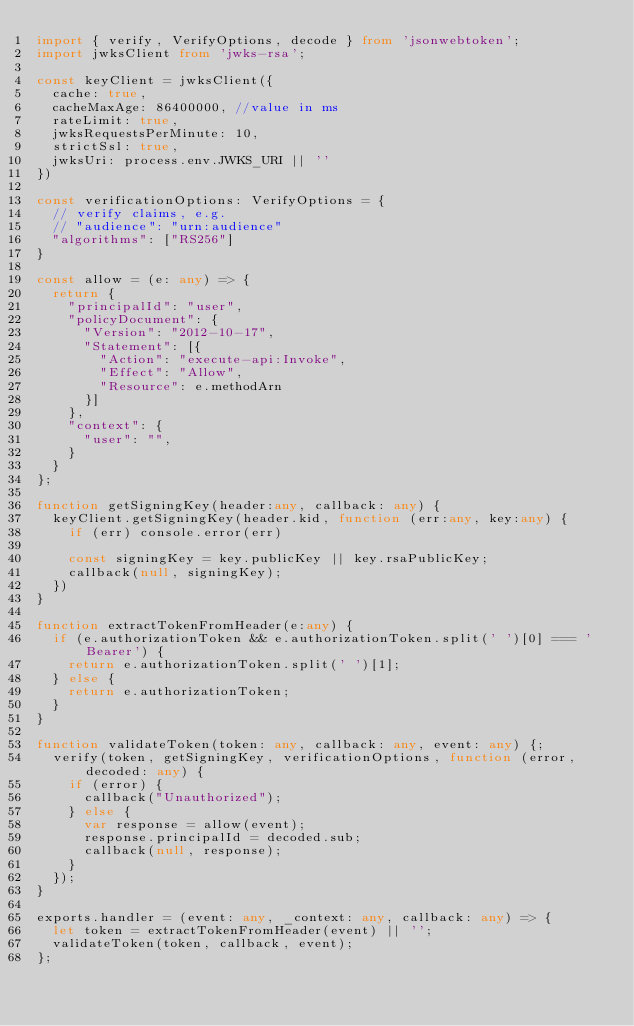<code> <loc_0><loc_0><loc_500><loc_500><_TypeScript_>import { verify, VerifyOptions, decode } from 'jsonwebtoken';
import jwksClient from 'jwks-rsa';

const keyClient = jwksClient({
  cache: true,
  cacheMaxAge: 86400000, //value in ms
  rateLimit: true,
  jwksRequestsPerMinute: 10,
  strictSsl: true,
  jwksUri: process.env.JWKS_URI || ''
})

const verificationOptions: VerifyOptions = {
  // verify claims, e.g.
  // "audience": "urn:audience"
  "algorithms": ["RS256"]
}

const allow = (e: any) => {
  return {
    "principalId": "user",
    "policyDocument": {
      "Version": "2012-10-17",
      "Statement": [{
        "Action": "execute-api:Invoke",
        "Effect": "Allow",
        "Resource": e.methodArn
      }]
    },
    "context": {
      "user": "",
    }
  }
};

function getSigningKey(header:any, callback: any) {
  keyClient.getSigningKey(header.kid, function (err:any, key:any) {
    if (err) console.error(err)

    const signingKey = key.publicKey || key.rsaPublicKey;
    callback(null, signingKey);
  })
}

function extractTokenFromHeader(e:any) {
  if (e.authorizationToken && e.authorizationToken.split(' ')[0] === 'Bearer') {
    return e.authorizationToken.split(' ')[1];
  } else {
    return e.authorizationToken;
  }
}

function validateToken(token: any, callback: any, event: any) {;
  verify(token, getSigningKey, verificationOptions, function (error, decoded: any) {
    if (error) {
      callback("Unauthorized");
    } else {
      var response = allow(event);
      response.principalId = decoded.sub;
      callback(null, response);
    }
  });
}

exports.handler = (event: any, _context: any, callback: any) => {
  let token = extractTokenFromHeader(event) || '';
  validateToken(token, callback, event);
};</code> 